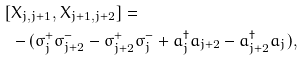<formula> <loc_0><loc_0><loc_500><loc_500>[ & X _ { j , j + 1 } , X _ { j + 1 , j + 2 } ] = \\ & - ( \sigma _ { j } ^ { + } \sigma _ { j + 2 } ^ { - } - \sigma _ { j + 2 } ^ { + } \sigma _ { j } ^ { - } + a _ { j } ^ { \dag } a _ { j + 2 } - a _ { j + 2 } ^ { \dag } a _ { j } ) ,</formula> 